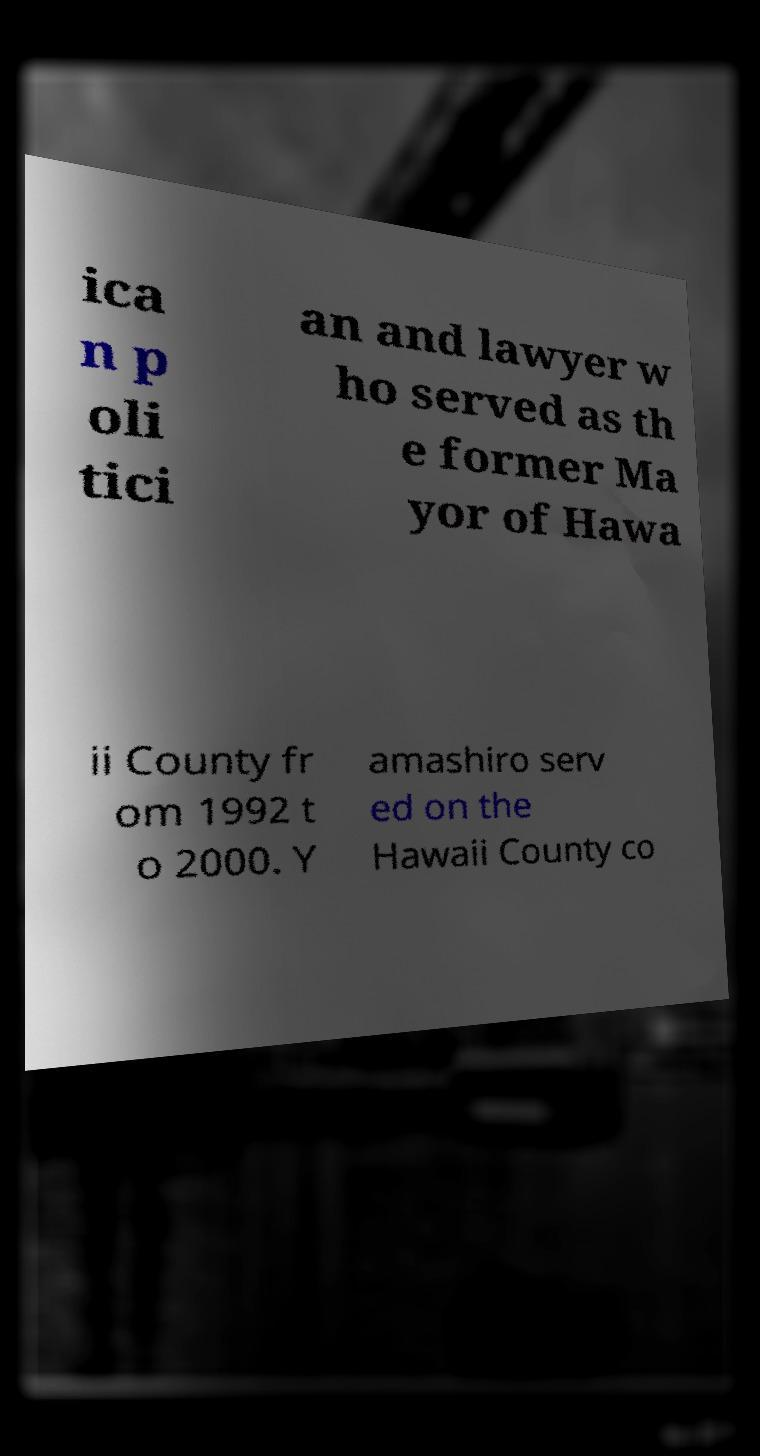What messages or text are displayed in this image? I need them in a readable, typed format. ica n p oli tici an and lawyer w ho served as th e former Ma yor of Hawa ii County fr om 1992 t o 2000. Y amashiro serv ed on the Hawaii County co 